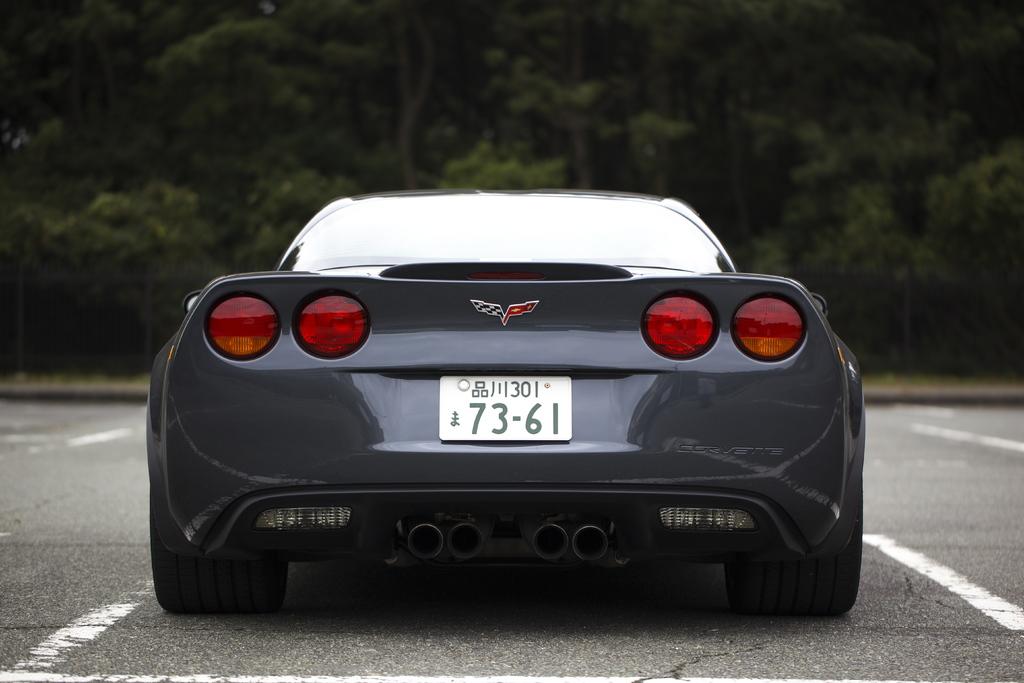What are the first 2 digits of the license plate number?
Make the answer very short. 73. What are the last two digits of the license plate?
Ensure brevity in your answer.  61. 